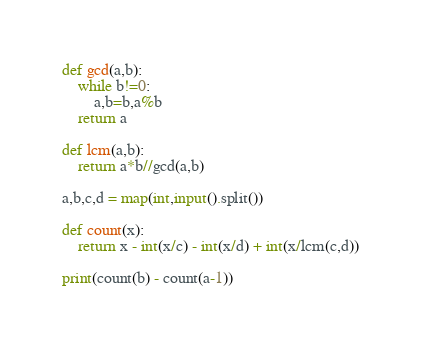<code> <loc_0><loc_0><loc_500><loc_500><_Python_>def gcd(a,b):
    while b!=0:
        a,b=b,a%b
    return a

def lcm(a,b):
    return a*b//gcd(a,b)

a,b,c,d = map(int,input().split())

def count(x):
    return x - int(x/c) - int(x/d) + int(x/lcm(c,d))

print(count(b) - count(a-1))
</code> 